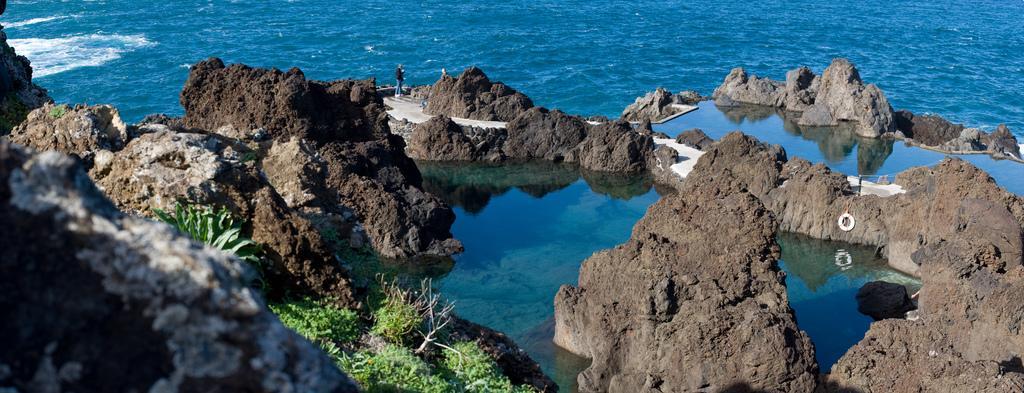Could you give a brief overview of what you see in this image? In this image, we can see a person and there is water, plants and rocks. 